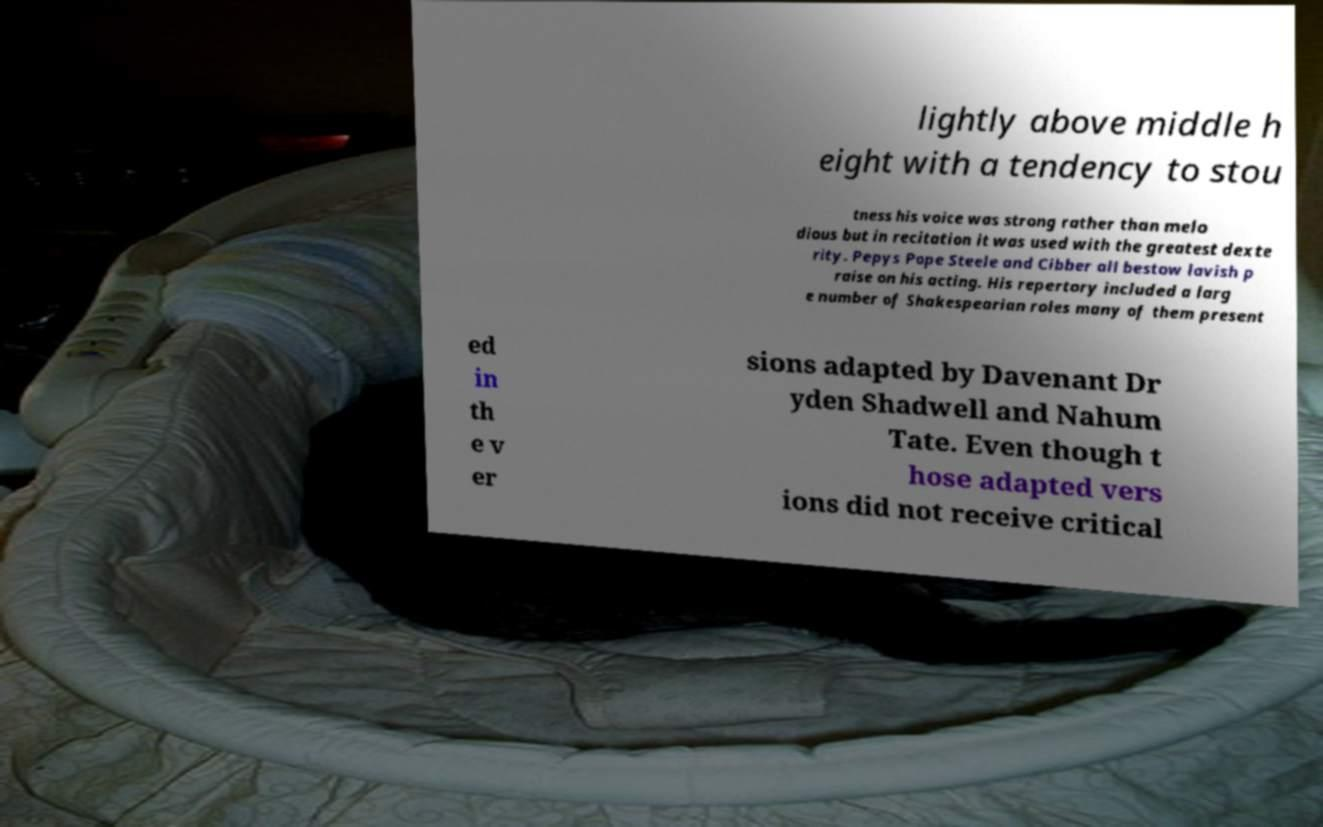Please identify and transcribe the text found in this image. lightly above middle h eight with a tendency to stou tness his voice was strong rather than melo dious but in recitation it was used with the greatest dexte rity. Pepys Pope Steele and Cibber all bestow lavish p raise on his acting. His repertory included a larg e number of Shakespearian roles many of them present ed in th e v er sions adapted by Davenant Dr yden Shadwell and Nahum Tate. Even though t hose adapted vers ions did not receive critical 